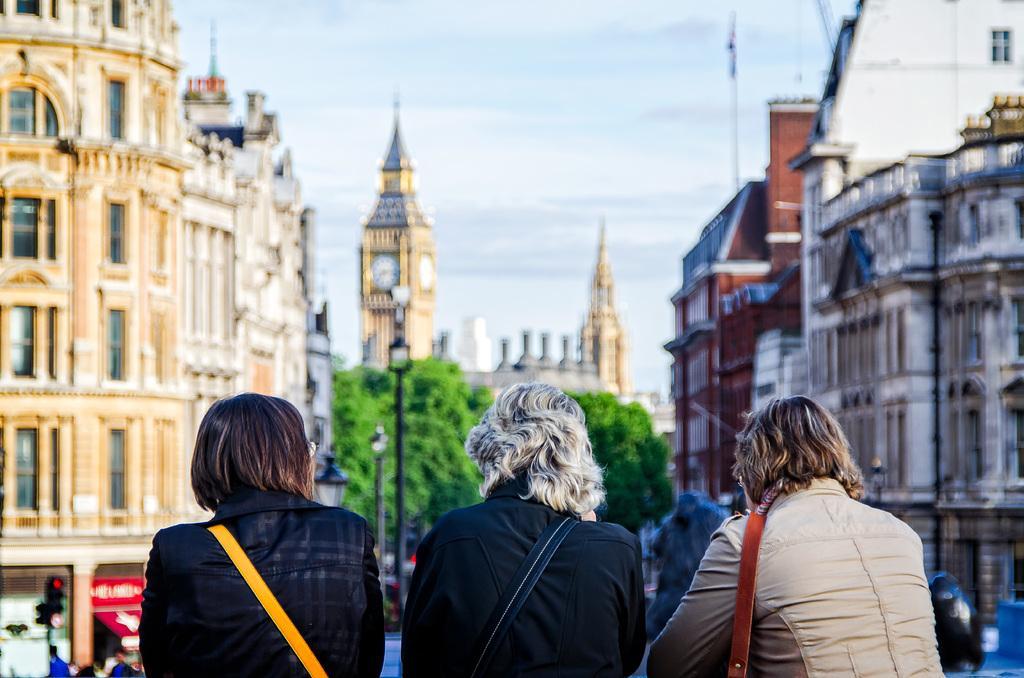In one or two sentences, can you explain what this image depicts? In the foreground I can see three persons are wearing bags. In the background I can see buildings, windows, trees, street lights, crowd on the road and towers. At the top I can see the sky. This image is taken may be on the road. 